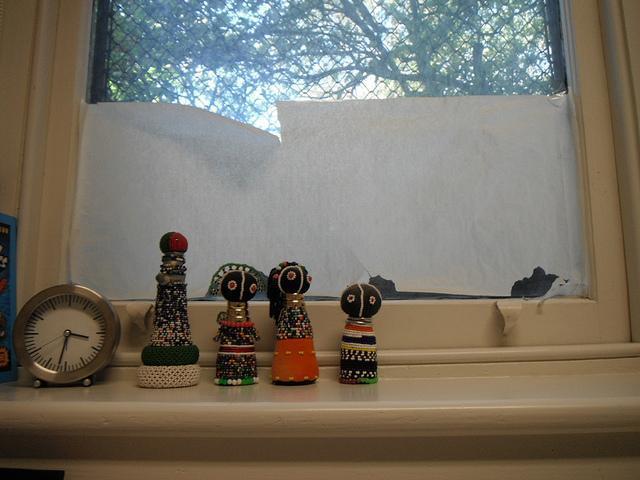How many objects is there?
Give a very brief answer. 5. How many tiers are on the cake?
Give a very brief answer. 0. 